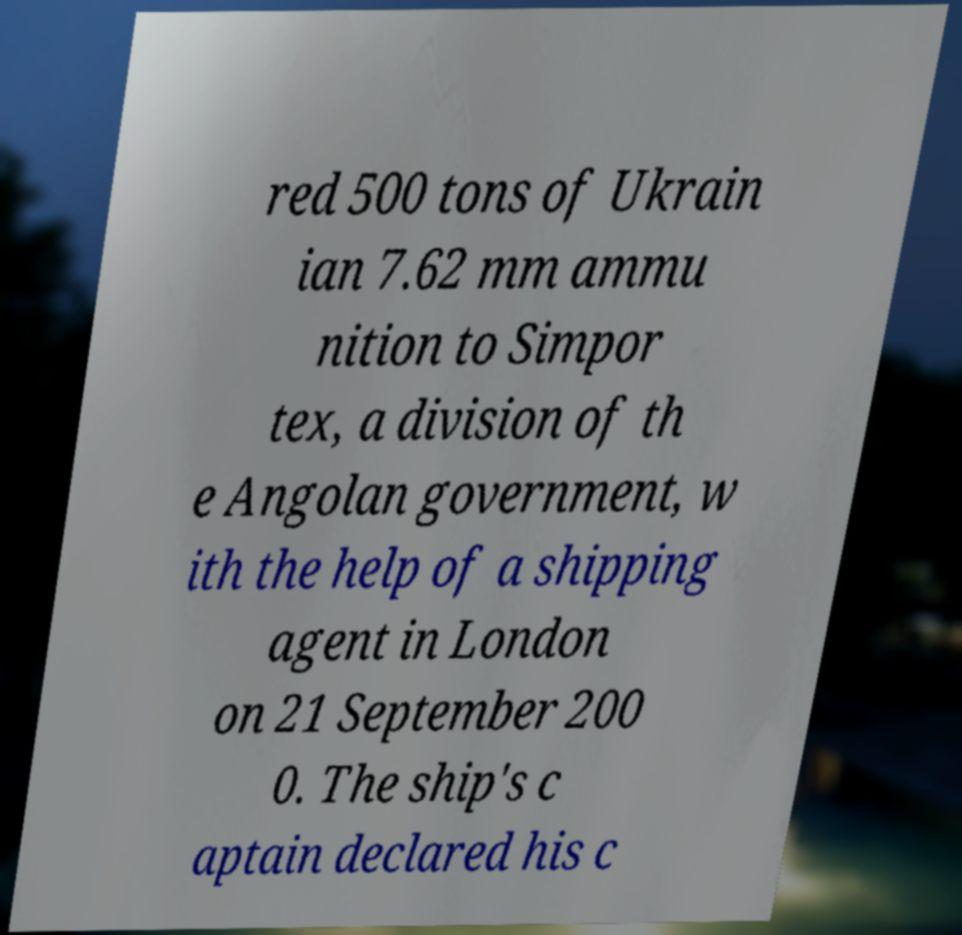There's text embedded in this image that I need extracted. Can you transcribe it verbatim? red 500 tons of Ukrain ian 7.62 mm ammu nition to Simpor tex, a division of th e Angolan government, w ith the help of a shipping agent in London on 21 September 200 0. The ship's c aptain declared his c 